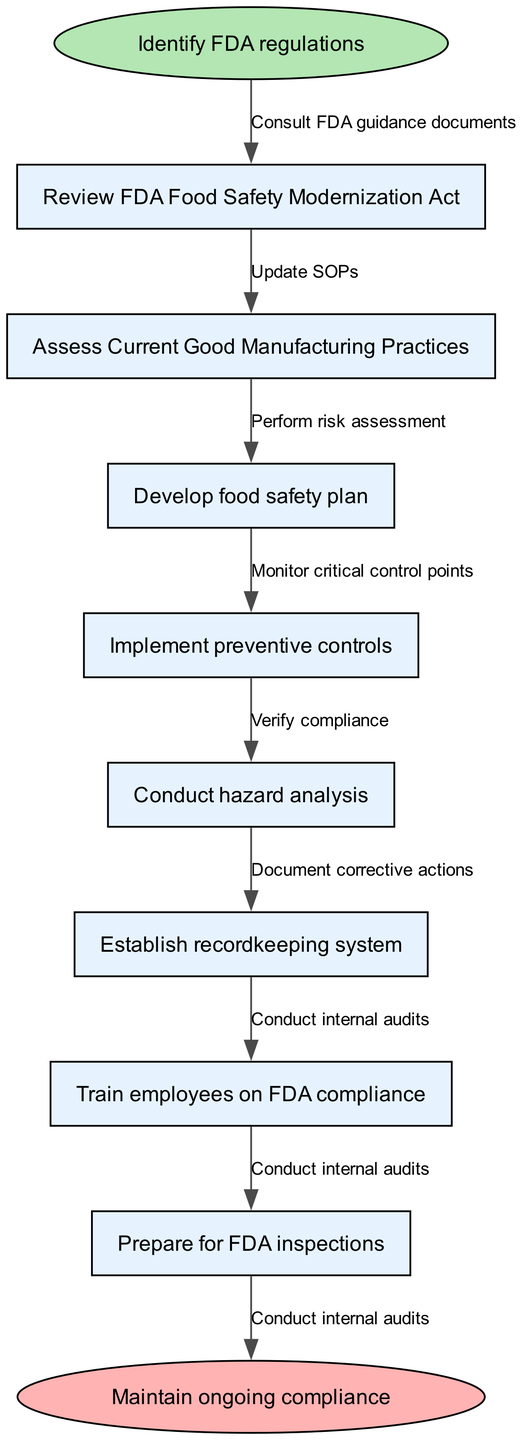What is the starting point of the workflow? The starting point of the workflow is clearly labeled as "Identify FDA regulations". This is the node from which the flow begins, indicated in the diagram.
Answer: Identify FDA regulations How many nodes are there in the diagram? The diagram contains a total of 9 nodes, including the start and end nodes. The nodes represent different steps in the workflow and are counted from the start to the end.
Answer: 9 What is the last step before maintaining ongoing compliance? The last step before reaching the end node "Maintain ongoing compliance" is "Conduct internal audits". This is directly connected to the end node in the workflow.
Answer: Conduct internal audits Which node follows "Develop food safety plan"? After "Develop food safety plan", the next node in the workflow is "Implement preventive controls". The flow connects these two steps sequentially.
Answer: Implement preventive controls What is the end point of the workflow? The endpoint of the workflow is labeled as "Maintain ongoing compliance". This node signifies the conclusion of the regulatory compliance process.
Answer: Maintain ongoing compliance Which edge connects "Review FDA Food Safety Modernization Act" to the next node? The edge that connects "Review FDA Food Safety Modernization Act" to its subsequent node is labeled "Consult FDA guidance documents". This edge facilitates the transition between these nodes in the workflow.
Answer: Consult FDA guidance documents How many edges are present in the diagram? There are 8 edges in the diagram, which represent the connections between the different nodes and indicate the flow of the process.
Answer: 8 What is the second node in the workflow? The second node in the workflow is "Review FDA Food Safety Modernization Act". This follows the starting node and is the first step in the sequence of compliance activities.
Answer: Review FDA Food Safety Modernization Act Which process directly follows hazard analysis in the compliance workflow? Following "Conduct hazard analysis", the next step in the workflow is "Establish recordkeeping system". This shows the order of actions in the food manufacturing compliance process.
Answer: Establish recordkeeping system 